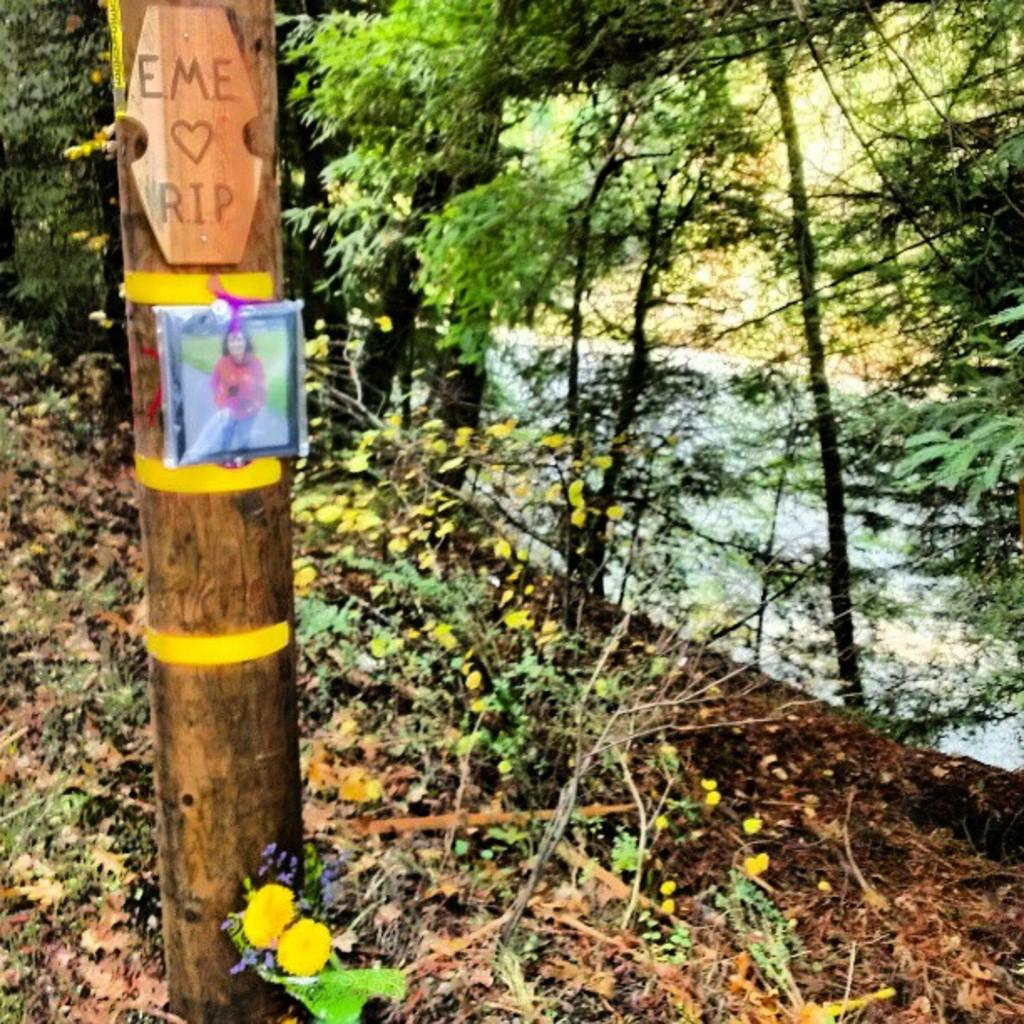What is the main object in the image? There is a pole in the image. What is hanging on the pole? There is a photo hanging on the pole. What type of objects can be seen in the image? There are wooden objects in the image. What type of natural elements can be seen in the image? There are flowers, trees, and plants in the image. What is visible in the background of the image? There are trees, plants, and other objects in the background of the image. How many rings are visible on the sisters' fingers in the image? There are no sisters or rings present in the image. What type of grape is being used as a decoration in the image? There is no grape present in the image. 